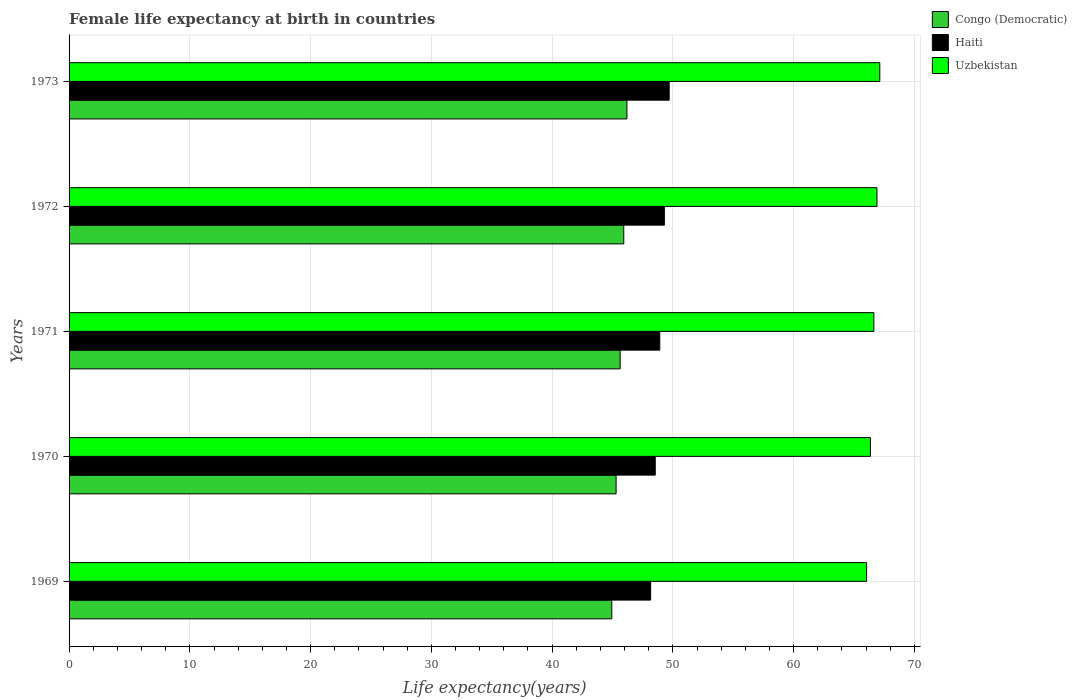How many groups of bars are there?
Provide a short and direct response. 5. How many bars are there on the 2nd tick from the top?
Give a very brief answer. 3. What is the label of the 3rd group of bars from the top?
Give a very brief answer. 1971. What is the female life expectancy at birth in Congo (Democratic) in 1970?
Provide a short and direct response. 45.3. Across all years, what is the maximum female life expectancy at birth in Uzbekistan?
Ensure brevity in your answer.  67.13. Across all years, what is the minimum female life expectancy at birth in Uzbekistan?
Make the answer very short. 66.04. In which year was the female life expectancy at birth in Congo (Democratic) maximum?
Provide a succinct answer. 1973. In which year was the female life expectancy at birth in Haiti minimum?
Make the answer very short. 1969. What is the total female life expectancy at birth in Haiti in the graph?
Offer a very short reply. 244.59. What is the difference between the female life expectancy at birth in Uzbekistan in 1972 and that in 1973?
Ensure brevity in your answer.  -0.23. What is the difference between the female life expectancy at birth in Uzbekistan in 1969 and the female life expectancy at birth in Haiti in 1972?
Make the answer very short. 16.74. What is the average female life expectancy at birth in Uzbekistan per year?
Give a very brief answer. 66.61. In the year 1970, what is the difference between the female life expectancy at birth in Uzbekistan and female life expectancy at birth in Haiti?
Your answer should be compact. 17.82. In how many years, is the female life expectancy at birth in Congo (Democratic) greater than 46 years?
Ensure brevity in your answer.  1. What is the ratio of the female life expectancy at birth in Haiti in 1971 to that in 1972?
Make the answer very short. 0.99. What is the difference between the highest and the second highest female life expectancy at birth in Uzbekistan?
Offer a terse response. 0.23. What is the difference between the highest and the lowest female life expectancy at birth in Uzbekistan?
Your response must be concise. 1.09. In how many years, is the female life expectancy at birth in Congo (Democratic) greater than the average female life expectancy at birth in Congo (Democratic) taken over all years?
Keep it short and to the point. 3. Is the sum of the female life expectancy at birth in Uzbekistan in 1971 and 1972 greater than the maximum female life expectancy at birth in Congo (Democratic) across all years?
Offer a terse response. Yes. What does the 2nd bar from the top in 1969 represents?
Your answer should be compact. Haiti. What does the 3rd bar from the bottom in 1972 represents?
Offer a terse response. Uzbekistan. How many years are there in the graph?
Offer a terse response. 5. Are the values on the major ticks of X-axis written in scientific E-notation?
Keep it short and to the point. No. Does the graph contain grids?
Ensure brevity in your answer.  Yes. What is the title of the graph?
Your response must be concise. Female life expectancy at birth in countries. Does "Spain" appear as one of the legend labels in the graph?
Ensure brevity in your answer.  No. What is the label or title of the X-axis?
Your answer should be compact. Life expectancy(years). What is the label or title of the Y-axis?
Your response must be concise. Years. What is the Life expectancy(years) in Congo (Democratic) in 1969?
Ensure brevity in your answer.  44.94. What is the Life expectancy(years) in Haiti in 1969?
Provide a succinct answer. 48.16. What is the Life expectancy(years) of Uzbekistan in 1969?
Provide a succinct answer. 66.04. What is the Life expectancy(years) in Congo (Democratic) in 1970?
Your answer should be very brief. 45.3. What is the Life expectancy(years) in Haiti in 1970?
Your response must be concise. 48.54. What is the Life expectancy(years) of Uzbekistan in 1970?
Your answer should be compact. 66.35. What is the Life expectancy(years) in Congo (Democratic) in 1971?
Offer a terse response. 45.63. What is the Life expectancy(years) of Haiti in 1971?
Ensure brevity in your answer.  48.91. What is the Life expectancy(years) in Uzbekistan in 1971?
Give a very brief answer. 66.64. What is the Life expectancy(years) in Congo (Democratic) in 1972?
Make the answer very short. 45.93. What is the Life expectancy(years) of Haiti in 1972?
Give a very brief answer. 49.29. What is the Life expectancy(years) of Uzbekistan in 1972?
Your response must be concise. 66.9. What is the Life expectancy(years) of Congo (Democratic) in 1973?
Offer a terse response. 46.19. What is the Life expectancy(years) in Haiti in 1973?
Keep it short and to the point. 49.69. What is the Life expectancy(years) of Uzbekistan in 1973?
Make the answer very short. 67.13. Across all years, what is the maximum Life expectancy(years) of Congo (Democratic)?
Give a very brief answer. 46.19. Across all years, what is the maximum Life expectancy(years) in Haiti?
Your response must be concise. 49.69. Across all years, what is the maximum Life expectancy(years) in Uzbekistan?
Your answer should be compact. 67.13. Across all years, what is the minimum Life expectancy(years) of Congo (Democratic)?
Provide a short and direct response. 44.94. Across all years, what is the minimum Life expectancy(years) of Haiti?
Keep it short and to the point. 48.16. Across all years, what is the minimum Life expectancy(years) of Uzbekistan?
Your response must be concise. 66.04. What is the total Life expectancy(years) in Congo (Democratic) in the graph?
Your answer should be compact. 227.99. What is the total Life expectancy(years) in Haiti in the graph?
Your answer should be very brief. 244.59. What is the total Life expectancy(years) of Uzbekistan in the graph?
Offer a terse response. 333.06. What is the difference between the Life expectancy(years) of Congo (Democratic) in 1969 and that in 1970?
Your answer should be very brief. -0.35. What is the difference between the Life expectancy(years) of Haiti in 1969 and that in 1970?
Ensure brevity in your answer.  -0.38. What is the difference between the Life expectancy(years) of Uzbekistan in 1969 and that in 1970?
Give a very brief answer. -0.32. What is the difference between the Life expectancy(years) in Congo (Democratic) in 1969 and that in 1971?
Ensure brevity in your answer.  -0.69. What is the difference between the Life expectancy(years) of Haiti in 1969 and that in 1971?
Give a very brief answer. -0.76. What is the difference between the Life expectancy(years) in Uzbekistan in 1969 and that in 1971?
Provide a short and direct response. -0.6. What is the difference between the Life expectancy(years) in Congo (Democratic) in 1969 and that in 1972?
Make the answer very short. -0.99. What is the difference between the Life expectancy(years) in Haiti in 1969 and that in 1972?
Ensure brevity in your answer.  -1.14. What is the difference between the Life expectancy(years) in Uzbekistan in 1969 and that in 1972?
Provide a succinct answer. -0.86. What is the difference between the Life expectancy(years) in Congo (Democratic) in 1969 and that in 1973?
Your answer should be compact. -1.25. What is the difference between the Life expectancy(years) in Haiti in 1969 and that in 1973?
Your answer should be compact. -1.53. What is the difference between the Life expectancy(years) of Uzbekistan in 1969 and that in 1973?
Provide a short and direct response. -1.09. What is the difference between the Life expectancy(years) of Congo (Democratic) in 1970 and that in 1971?
Offer a terse response. -0.34. What is the difference between the Life expectancy(years) in Haiti in 1970 and that in 1971?
Offer a very short reply. -0.38. What is the difference between the Life expectancy(years) in Uzbekistan in 1970 and that in 1971?
Your answer should be compact. -0.29. What is the difference between the Life expectancy(years) of Congo (Democratic) in 1970 and that in 1972?
Your response must be concise. -0.64. What is the difference between the Life expectancy(years) in Haiti in 1970 and that in 1972?
Your answer should be very brief. -0.76. What is the difference between the Life expectancy(years) of Uzbekistan in 1970 and that in 1972?
Make the answer very short. -0.54. What is the difference between the Life expectancy(years) in Congo (Democratic) in 1970 and that in 1973?
Your response must be concise. -0.9. What is the difference between the Life expectancy(years) of Haiti in 1970 and that in 1973?
Make the answer very short. -1.15. What is the difference between the Life expectancy(years) in Uzbekistan in 1970 and that in 1973?
Make the answer very short. -0.78. What is the difference between the Life expectancy(years) of Congo (Democratic) in 1971 and that in 1972?
Offer a very short reply. -0.3. What is the difference between the Life expectancy(years) of Haiti in 1971 and that in 1972?
Provide a short and direct response. -0.38. What is the difference between the Life expectancy(years) in Uzbekistan in 1971 and that in 1972?
Your answer should be compact. -0.26. What is the difference between the Life expectancy(years) of Congo (Democratic) in 1971 and that in 1973?
Make the answer very short. -0.56. What is the difference between the Life expectancy(years) of Haiti in 1971 and that in 1973?
Your answer should be very brief. -0.78. What is the difference between the Life expectancy(years) in Uzbekistan in 1971 and that in 1973?
Provide a succinct answer. -0.49. What is the difference between the Life expectancy(years) in Congo (Democratic) in 1972 and that in 1973?
Provide a short and direct response. -0.26. What is the difference between the Life expectancy(years) of Haiti in 1972 and that in 1973?
Give a very brief answer. -0.4. What is the difference between the Life expectancy(years) in Uzbekistan in 1972 and that in 1973?
Provide a succinct answer. -0.23. What is the difference between the Life expectancy(years) in Congo (Democratic) in 1969 and the Life expectancy(years) in Haiti in 1970?
Give a very brief answer. -3.6. What is the difference between the Life expectancy(years) in Congo (Democratic) in 1969 and the Life expectancy(years) in Uzbekistan in 1970?
Make the answer very short. -21.41. What is the difference between the Life expectancy(years) in Haiti in 1969 and the Life expectancy(years) in Uzbekistan in 1970?
Your answer should be compact. -18.2. What is the difference between the Life expectancy(years) in Congo (Democratic) in 1969 and the Life expectancy(years) in Haiti in 1971?
Your answer should be very brief. -3.97. What is the difference between the Life expectancy(years) of Congo (Democratic) in 1969 and the Life expectancy(years) of Uzbekistan in 1971?
Your answer should be very brief. -21.7. What is the difference between the Life expectancy(years) of Haiti in 1969 and the Life expectancy(years) of Uzbekistan in 1971?
Provide a short and direct response. -18.48. What is the difference between the Life expectancy(years) of Congo (Democratic) in 1969 and the Life expectancy(years) of Haiti in 1972?
Offer a very short reply. -4.35. What is the difference between the Life expectancy(years) of Congo (Democratic) in 1969 and the Life expectancy(years) of Uzbekistan in 1972?
Your response must be concise. -21.96. What is the difference between the Life expectancy(years) of Haiti in 1969 and the Life expectancy(years) of Uzbekistan in 1972?
Ensure brevity in your answer.  -18.74. What is the difference between the Life expectancy(years) in Congo (Democratic) in 1969 and the Life expectancy(years) in Haiti in 1973?
Offer a very short reply. -4.75. What is the difference between the Life expectancy(years) in Congo (Democratic) in 1969 and the Life expectancy(years) in Uzbekistan in 1973?
Keep it short and to the point. -22.19. What is the difference between the Life expectancy(years) of Haiti in 1969 and the Life expectancy(years) of Uzbekistan in 1973?
Offer a very short reply. -18.97. What is the difference between the Life expectancy(years) of Congo (Democratic) in 1970 and the Life expectancy(years) of Haiti in 1971?
Give a very brief answer. -3.62. What is the difference between the Life expectancy(years) in Congo (Democratic) in 1970 and the Life expectancy(years) in Uzbekistan in 1971?
Give a very brief answer. -21.34. What is the difference between the Life expectancy(years) of Haiti in 1970 and the Life expectancy(years) of Uzbekistan in 1971?
Provide a succinct answer. -18.1. What is the difference between the Life expectancy(years) of Congo (Democratic) in 1970 and the Life expectancy(years) of Haiti in 1972?
Make the answer very short. -4. What is the difference between the Life expectancy(years) of Congo (Democratic) in 1970 and the Life expectancy(years) of Uzbekistan in 1972?
Keep it short and to the point. -21.6. What is the difference between the Life expectancy(years) of Haiti in 1970 and the Life expectancy(years) of Uzbekistan in 1972?
Offer a terse response. -18.36. What is the difference between the Life expectancy(years) of Congo (Democratic) in 1970 and the Life expectancy(years) of Haiti in 1973?
Offer a very short reply. -4.39. What is the difference between the Life expectancy(years) in Congo (Democratic) in 1970 and the Life expectancy(years) in Uzbekistan in 1973?
Your answer should be compact. -21.84. What is the difference between the Life expectancy(years) in Haiti in 1970 and the Life expectancy(years) in Uzbekistan in 1973?
Ensure brevity in your answer.  -18.59. What is the difference between the Life expectancy(years) of Congo (Democratic) in 1971 and the Life expectancy(years) of Haiti in 1972?
Offer a very short reply. -3.66. What is the difference between the Life expectancy(years) in Congo (Democratic) in 1971 and the Life expectancy(years) in Uzbekistan in 1972?
Offer a very short reply. -21.27. What is the difference between the Life expectancy(years) in Haiti in 1971 and the Life expectancy(years) in Uzbekistan in 1972?
Ensure brevity in your answer.  -17.98. What is the difference between the Life expectancy(years) in Congo (Democratic) in 1971 and the Life expectancy(years) in Haiti in 1973?
Your answer should be very brief. -4.06. What is the difference between the Life expectancy(years) in Congo (Democratic) in 1971 and the Life expectancy(years) in Uzbekistan in 1973?
Your answer should be very brief. -21.5. What is the difference between the Life expectancy(years) in Haiti in 1971 and the Life expectancy(years) in Uzbekistan in 1973?
Your answer should be very brief. -18.22. What is the difference between the Life expectancy(years) of Congo (Democratic) in 1972 and the Life expectancy(years) of Haiti in 1973?
Provide a succinct answer. -3.76. What is the difference between the Life expectancy(years) in Congo (Democratic) in 1972 and the Life expectancy(years) in Uzbekistan in 1973?
Your answer should be very brief. -21.2. What is the difference between the Life expectancy(years) of Haiti in 1972 and the Life expectancy(years) of Uzbekistan in 1973?
Make the answer very short. -17.84. What is the average Life expectancy(years) of Congo (Democratic) per year?
Ensure brevity in your answer.  45.6. What is the average Life expectancy(years) in Haiti per year?
Ensure brevity in your answer.  48.92. What is the average Life expectancy(years) of Uzbekistan per year?
Your response must be concise. 66.61. In the year 1969, what is the difference between the Life expectancy(years) of Congo (Democratic) and Life expectancy(years) of Haiti?
Provide a short and direct response. -3.22. In the year 1969, what is the difference between the Life expectancy(years) of Congo (Democratic) and Life expectancy(years) of Uzbekistan?
Provide a succinct answer. -21.1. In the year 1969, what is the difference between the Life expectancy(years) of Haiti and Life expectancy(years) of Uzbekistan?
Keep it short and to the point. -17.88. In the year 1970, what is the difference between the Life expectancy(years) of Congo (Democratic) and Life expectancy(years) of Haiti?
Your answer should be very brief. -3.24. In the year 1970, what is the difference between the Life expectancy(years) of Congo (Democratic) and Life expectancy(years) of Uzbekistan?
Make the answer very short. -21.06. In the year 1970, what is the difference between the Life expectancy(years) in Haiti and Life expectancy(years) in Uzbekistan?
Ensure brevity in your answer.  -17.82. In the year 1971, what is the difference between the Life expectancy(years) in Congo (Democratic) and Life expectancy(years) in Haiti?
Your answer should be compact. -3.28. In the year 1971, what is the difference between the Life expectancy(years) of Congo (Democratic) and Life expectancy(years) of Uzbekistan?
Keep it short and to the point. -21.01. In the year 1971, what is the difference between the Life expectancy(years) in Haiti and Life expectancy(years) in Uzbekistan?
Your answer should be very brief. -17.73. In the year 1972, what is the difference between the Life expectancy(years) in Congo (Democratic) and Life expectancy(years) in Haiti?
Ensure brevity in your answer.  -3.36. In the year 1972, what is the difference between the Life expectancy(years) in Congo (Democratic) and Life expectancy(years) in Uzbekistan?
Your response must be concise. -20.97. In the year 1972, what is the difference between the Life expectancy(years) in Haiti and Life expectancy(years) in Uzbekistan?
Your answer should be very brief. -17.6. In the year 1973, what is the difference between the Life expectancy(years) of Congo (Democratic) and Life expectancy(years) of Haiti?
Provide a short and direct response. -3.5. In the year 1973, what is the difference between the Life expectancy(years) in Congo (Democratic) and Life expectancy(years) in Uzbekistan?
Give a very brief answer. -20.94. In the year 1973, what is the difference between the Life expectancy(years) in Haiti and Life expectancy(years) in Uzbekistan?
Make the answer very short. -17.44. What is the ratio of the Life expectancy(years) of Congo (Democratic) in 1969 to that in 1970?
Ensure brevity in your answer.  0.99. What is the ratio of the Life expectancy(years) of Haiti in 1969 to that in 1970?
Give a very brief answer. 0.99. What is the ratio of the Life expectancy(years) in Uzbekistan in 1969 to that in 1970?
Offer a very short reply. 1. What is the ratio of the Life expectancy(years) in Congo (Democratic) in 1969 to that in 1971?
Make the answer very short. 0.98. What is the ratio of the Life expectancy(years) of Haiti in 1969 to that in 1971?
Make the answer very short. 0.98. What is the ratio of the Life expectancy(years) in Uzbekistan in 1969 to that in 1971?
Offer a very short reply. 0.99. What is the ratio of the Life expectancy(years) in Congo (Democratic) in 1969 to that in 1972?
Give a very brief answer. 0.98. What is the ratio of the Life expectancy(years) of Uzbekistan in 1969 to that in 1972?
Your response must be concise. 0.99. What is the ratio of the Life expectancy(years) in Congo (Democratic) in 1969 to that in 1973?
Keep it short and to the point. 0.97. What is the ratio of the Life expectancy(years) in Haiti in 1969 to that in 1973?
Your answer should be very brief. 0.97. What is the ratio of the Life expectancy(years) of Uzbekistan in 1969 to that in 1973?
Make the answer very short. 0.98. What is the ratio of the Life expectancy(years) in Congo (Democratic) in 1970 to that in 1971?
Your answer should be compact. 0.99. What is the ratio of the Life expectancy(years) in Congo (Democratic) in 1970 to that in 1972?
Your answer should be compact. 0.99. What is the ratio of the Life expectancy(years) in Haiti in 1970 to that in 1972?
Keep it short and to the point. 0.98. What is the ratio of the Life expectancy(years) of Uzbekistan in 1970 to that in 1972?
Your response must be concise. 0.99. What is the ratio of the Life expectancy(years) of Congo (Democratic) in 1970 to that in 1973?
Your answer should be compact. 0.98. What is the ratio of the Life expectancy(years) in Haiti in 1970 to that in 1973?
Your answer should be very brief. 0.98. What is the ratio of the Life expectancy(years) in Uzbekistan in 1970 to that in 1973?
Your response must be concise. 0.99. What is the ratio of the Life expectancy(years) in Congo (Democratic) in 1971 to that in 1972?
Offer a terse response. 0.99. What is the ratio of the Life expectancy(years) in Haiti in 1971 to that in 1972?
Your response must be concise. 0.99. What is the ratio of the Life expectancy(years) of Uzbekistan in 1971 to that in 1972?
Offer a terse response. 1. What is the ratio of the Life expectancy(years) of Congo (Democratic) in 1971 to that in 1973?
Offer a terse response. 0.99. What is the ratio of the Life expectancy(years) of Haiti in 1971 to that in 1973?
Ensure brevity in your answer.  0.98. What is the ratio of the Life expectancy(years) of Uzbekistan in 1972 to that in 1973?
Provide a succinct answer. 1. What is the difference between the highest and the second highest Life expectancy(years) of Congo (Democratic)?
Provide a short and direct response. 0.26. What is the difference between the highest and the second highest Life expectancy(years) in Haiti?
Provide a short and direct response. 0.4. What is the difference between the highest and the second highest Life expectancy(years) of Uzbekistan?
Your answer should be very brief. 0.23. What is the difference between the highest and the lowest Life expectancy(years) of Congo (Democratic)?
Keep it short and to the point. 1.25. What is the difference between the highest and the lowest Life expectancy(years) of Haiti?
Give a very brief answer. 1.53. What is the difference between the highest and the lowest Life expectancy(years) in Uzbekistan?
Your response must be concise. 1.09. 